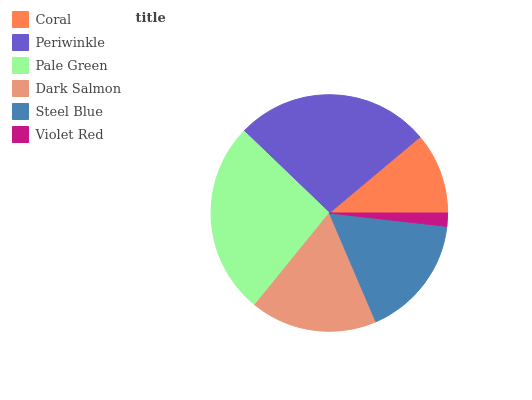Is Violet Red the minimum?
Answer yes or no. Yes. Is Periwinkle the maximum?
Answer yes or no. Yes. Is Pale Green the minimum?
Answer yes or no. No. Is Pale Green the maximum?
Answer yes or no. No. Is Periwinkle greater than Pale Green?
Answer yes or no. Yes. Is Pale Green less than Periwinkle?
Answer yes or no. Yes. Is Pale Green greater than Periwinkle?
Answer yes or no. No. Is Periwinkle less than Pale Green?
Answer yes or no. No. Is Dark Salmon the high median?
Answer yes or no. Yes. Is Steel Blue the low median?
Answer yes or no. Yes. Is Coral the high median?
Answer yes or no. No. Is Periwinkle the low median?
Answer yes or no. No. 